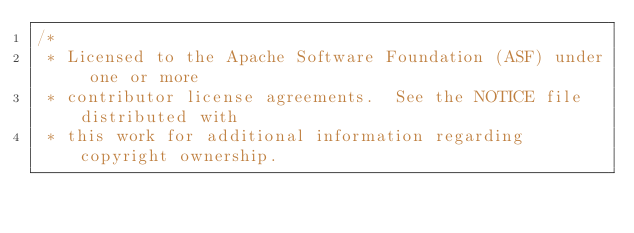Convert code to text. <code><loc_0><loc_0><loc_500><loc_500><_Java_>/*
 * Licensed to the Apache Software Foundation (ASF) under one or more
 * contributor license agreements.  See the NOTICE file distributed with
 * this work for additional information regarding copyright ownership.</code> 